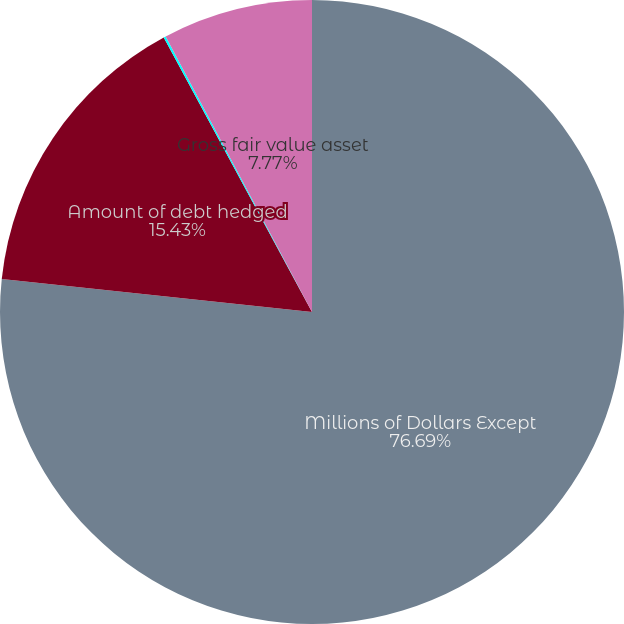<chart> <loc_0><loc_0><loc_500><loc_500><pie_chart><fcel>Millions of Dollars Except<fcel>Amount of debt hedged<fcel>Percentage of total debt<fcel>Gross fair value asset<nl><fcel>76.69%<fcel>15.43%<fcel>0.11%<fcel>7.77%<nl></chart> 